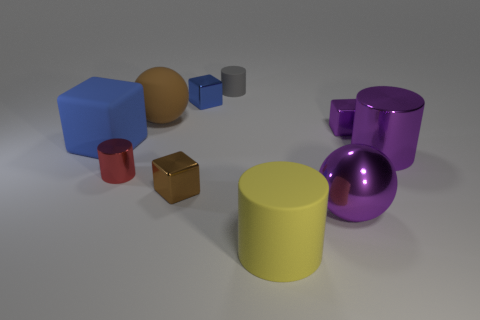Subtract all tiny shiny cubes. How many cubes are left? 1 Subtract all purple blocks. How many blocks are left? 3 Subtract all yellow spheres. How many blue cubes are left? 2 Subtract 2 cylinders. How many cylinders are left? 2 Subtract all spheres. How many objects are left? 8 Subtract all spheres. Subtract all big metallic things. How many objects are left? 6 Add 4 small cylinders. How many small cylinders are left? 6 Add 2 brown objects. How many brown objects exist? 4 Subtract 1 purple blocks. How many objects are left? 9 Subtract all red blocks. Subtract all blue cylinders. How many blocks are left? 4 